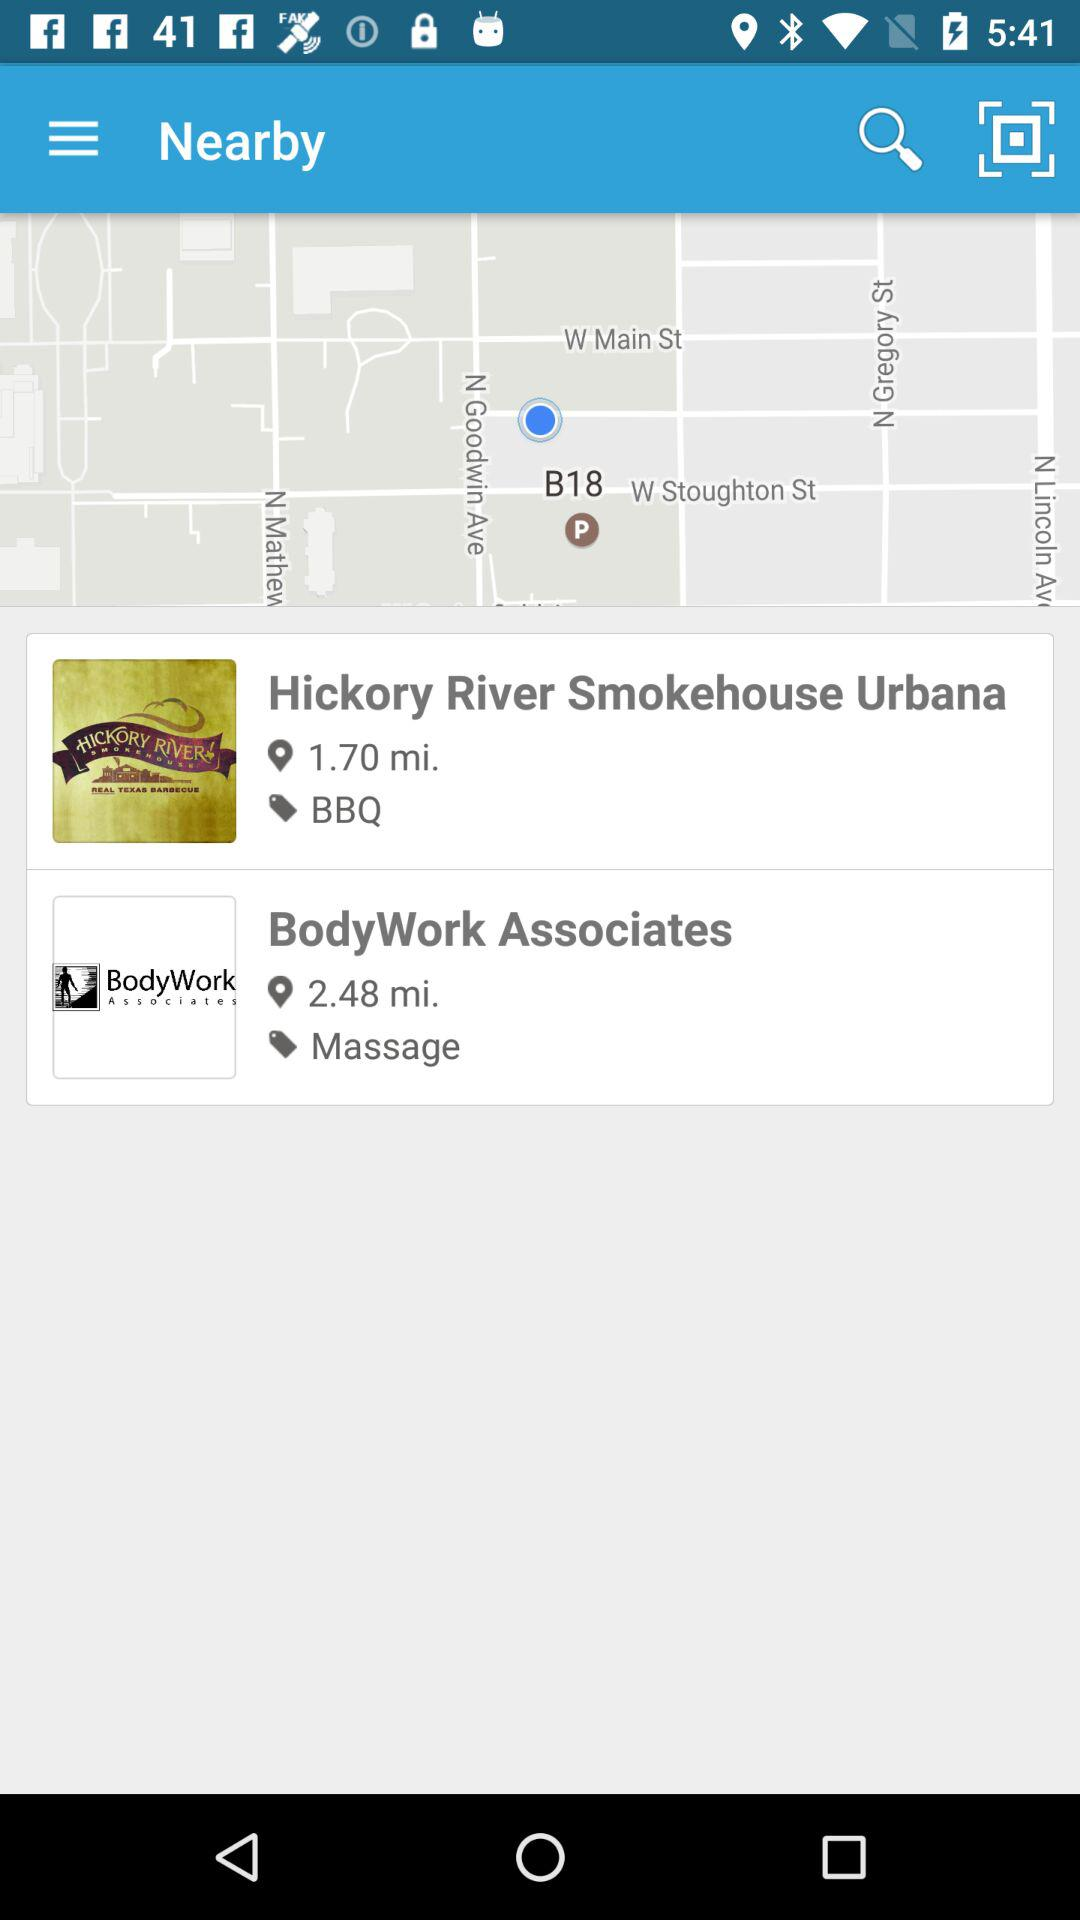How many more miles is BodyWork Associates than Hickory River Smokehouse?
Answer the question using a single word or phrase. 0.78 